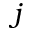<formula> <loc_0><loc_0><loc_500><loc_500>j</formula> 